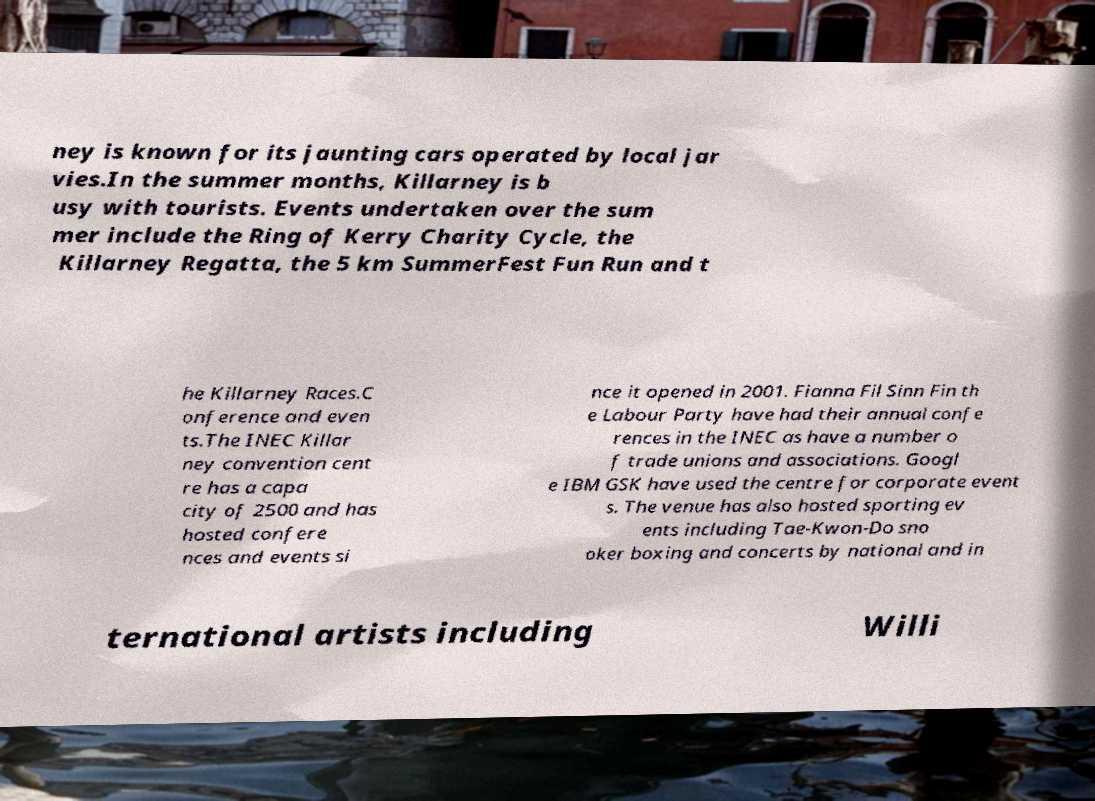Please read and relay the text visible in this image. What does it say? ney is known for its jaunting cars operated by local jar vies.In the summer months, Killarney is b usy with tourists. Events undertaken over the sum mer include the Ring of Kerry Charity Cycle, the Killarney Regatta, the 5 km SummerFest Fun Run and t he Killarney Races.C onference and even ts.The INEC Killar ney convention cent re has a capa city of 2500 and has hosted confere nces and events si nce it opened in 2001. Fianna Fil Sinn Fin th e Labour Party have had their annual confe rences in the INEC as have a number o f trade unions and associations. Googl e IBM GSK have used the centre for corporate event s. The venue has also hosted sporting ev ents including Tae-Kwon-Do sno oker boxing and concerts by national and in ternational artists including Willi 